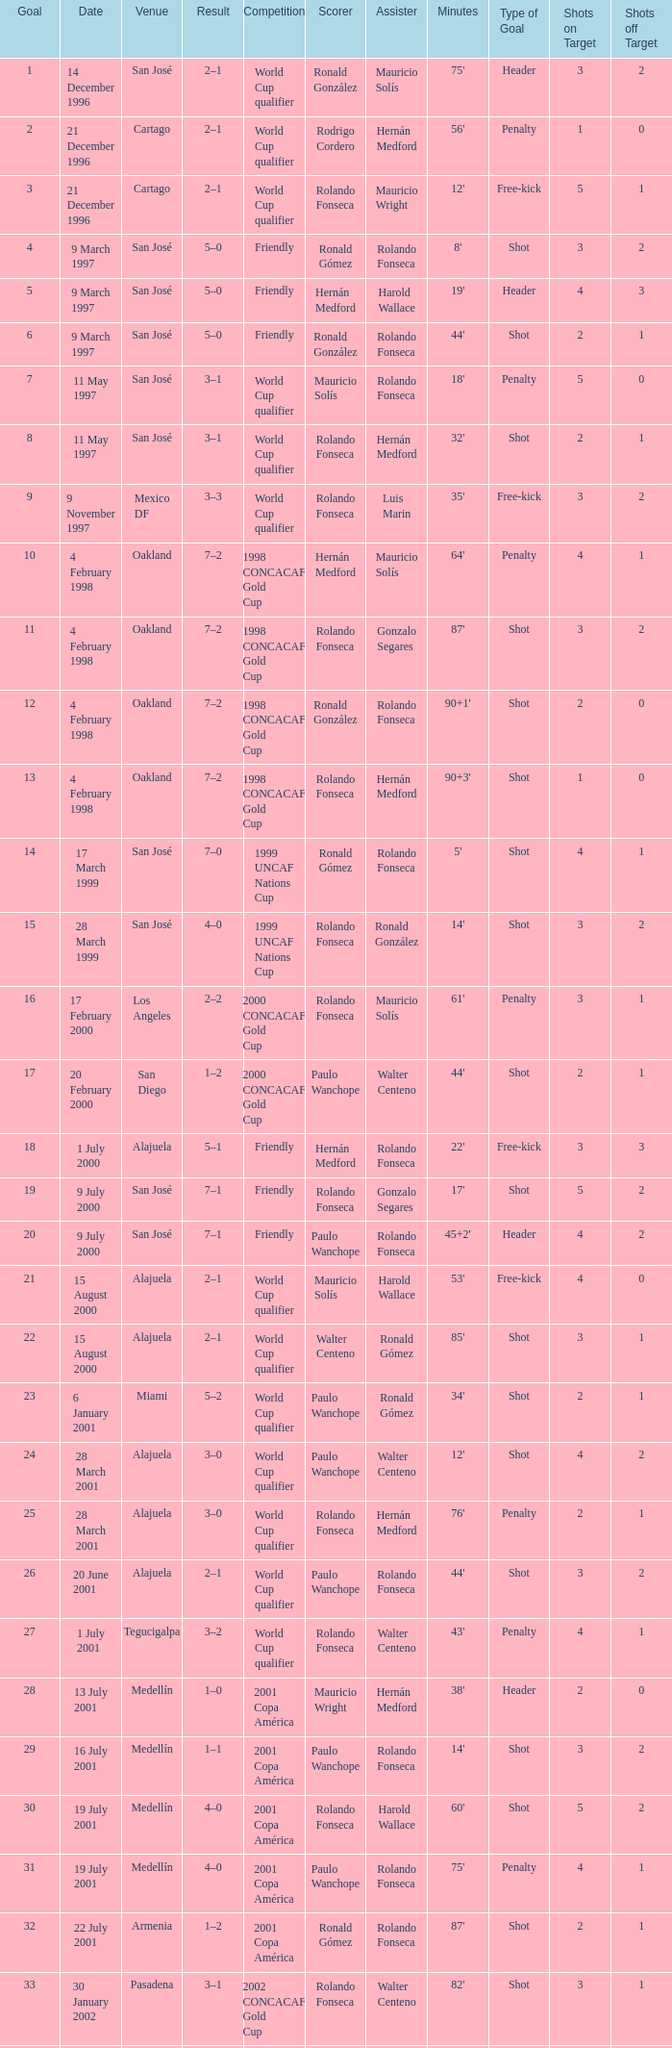What is the result in oakland? 7–2, 7–2, 7–2, 7–2. 